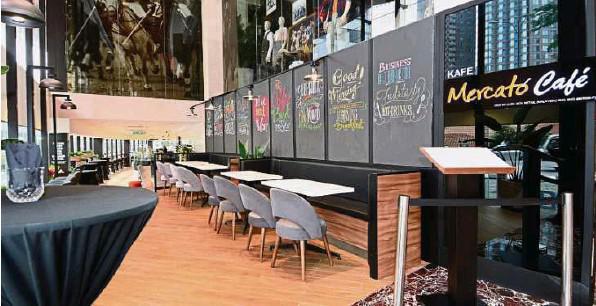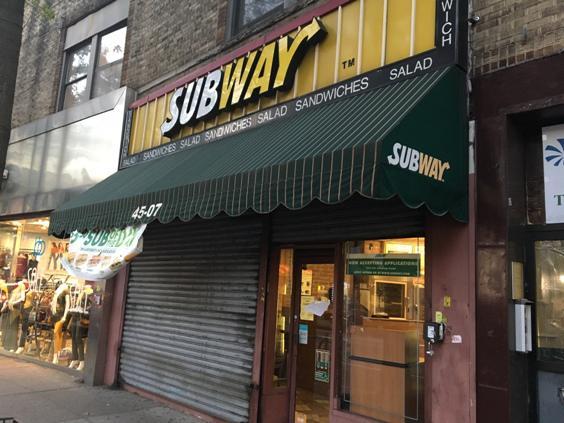The first image is the image on the left, the second image is the image on the right. Analyze the images presented: Is the assertion "One of the restaurants has several customers sitting in chairs." valid? Answer yes or no. No. The first image is the image on the left, the second image is the image on the right. Evaluate the accuracy of this statement regarding the images: "There are two cafes with internal views.". Is it true? Answer yes or no. No. 